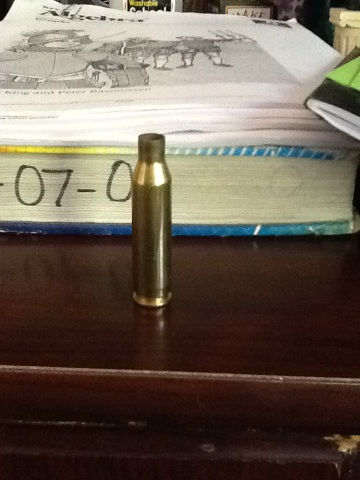How can one safely dispose of this object? To safely dispose of a brass bullet casing, it's best to take it to a local recycling facility that handles metals. Ensure it is not loaded and consult local regulations on the disposal of items connected to firearms. 